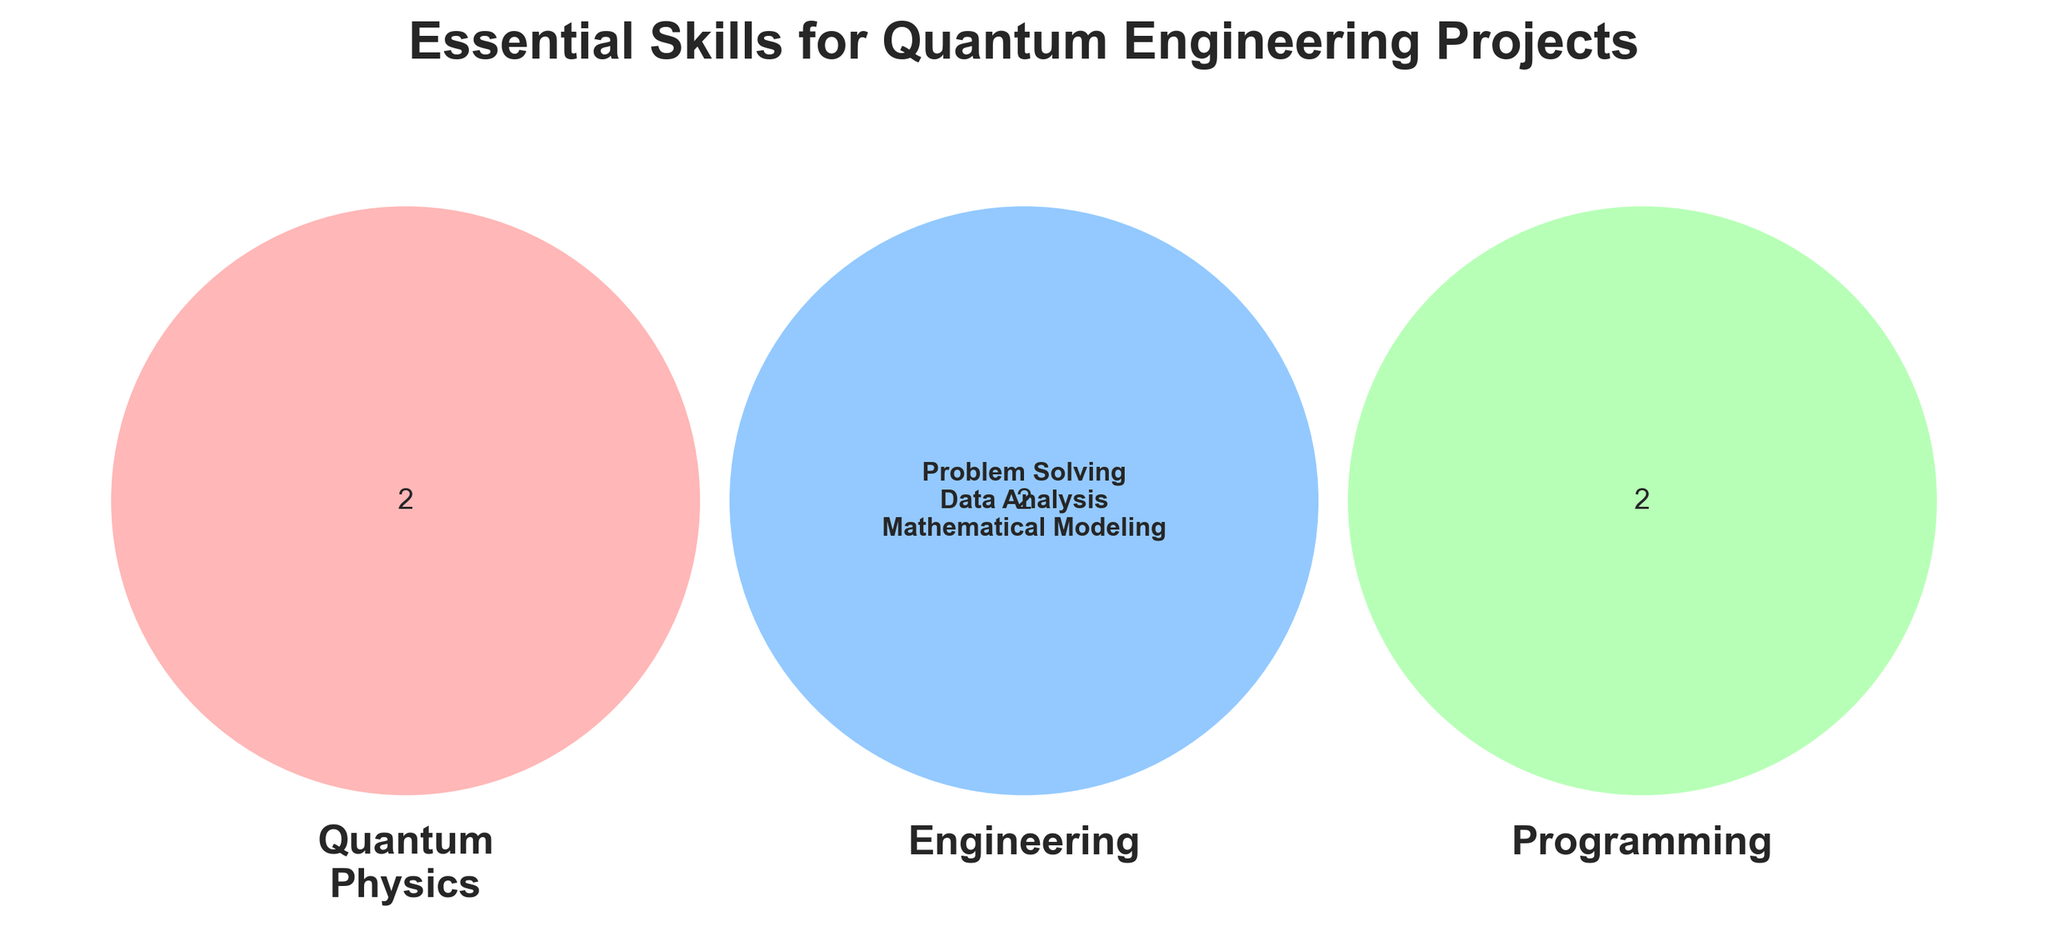What is the title of the Venn diagram? The title is usually located at the top of the diagram and should denote the main subject of the illustration. In this case, the title is "Essential Skills for Quantum Engineering Projects".
Answer: Essential Skills for Quantum Engineering Projects How many skills are listed in the shared section of the Venn diagram? To determine this, look at the center text of the Venn diagram where the shared skills among all categories are displayed. Count each skill mentioned.
Answer: 3 Which categories are compared in the Venn diagram? The labels around the Venn diagram indicate the different categories being compared. Here, there are three categories: "Quantum Physics", "Engineering", and "Programming".
Answer: Quantum Physics, Engineering, Programming What are the skills specific to Quantum Physics? Check the section only covered by the "Quantum Physics" circle in the Venn diagram. The skills specific to this category are listed there.
Answer: Quantum Mechanics, Quantum Information Theory Which skills are common to all three categories? Skills common across all three categories will be found in the center where the three circles overlap. Read each skill listed in this central area.
Answer: Mathematical Modeling, Problem Solving, Data Analysis Compare the number of skills unique to Engineering and Programming. Which has more? Count the number of unique skills listed in the "Engineering" section and the "Programming" section, then compare these counts to determine which is higher.
Answer: Engineering How many skills are exclusive to the Programming category? Look at the section of the diagram only covered by the "Programming" circle. Count the individual skills mentioned in this area to find how many there are.
Answer: 2 What unique skills do Engineering and Quantum Physics have, respectively? Identify and list the skills found exclusively in the "Engineering" section and the skills found exclusively in the "Quantum Physics" section of the Venn diagram.
Answer: Engineering: Circuit Design, Systems Integration; Quantum Physics: Quantum Mechanics, Quantum Information Theory Which two categories share the "Mathematical Modeling" skill? To determine this, observe the overlapping sections of the Venn diagram. "Mathematical Modeling" appears in the central section, indicating it is shared among all three categories: Quantum Physics, Engineering, and Programming.
Answer: Quantum Physics, Engineering, Programming 